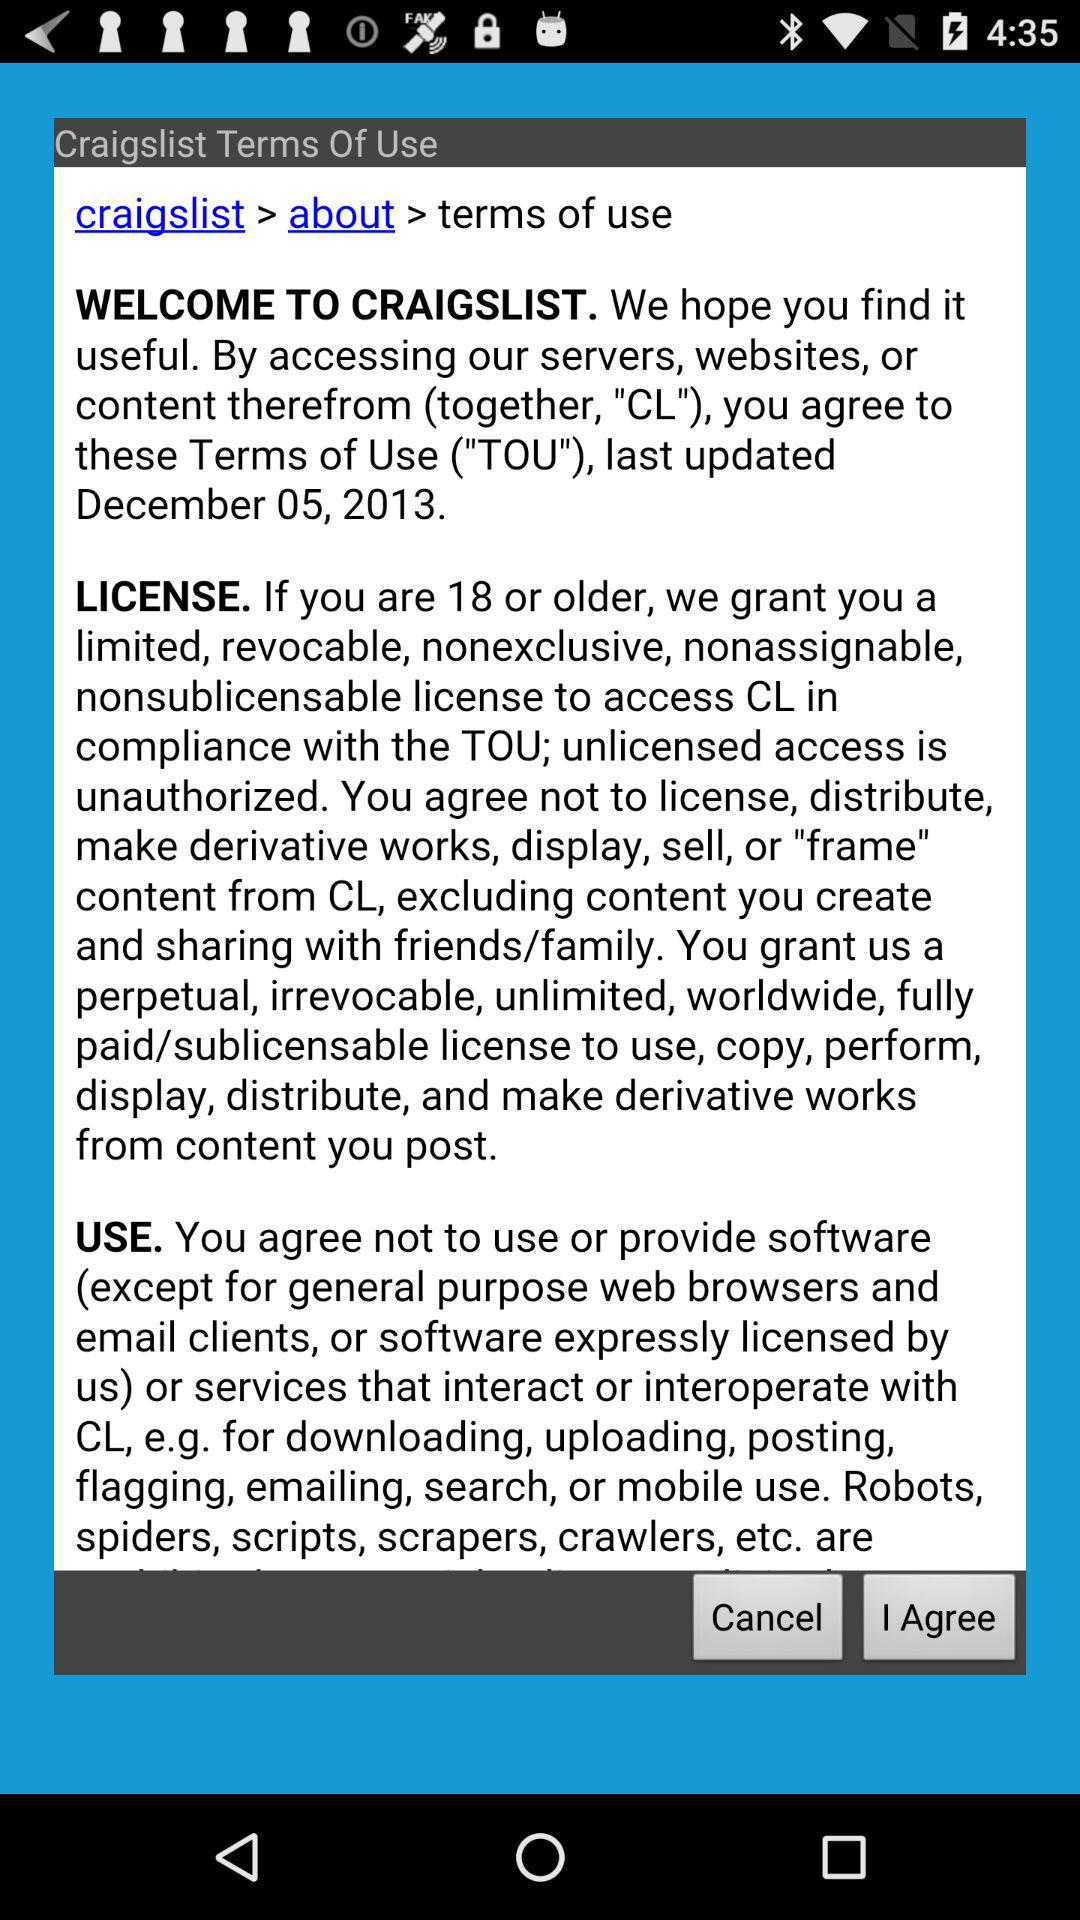What is the age limit for the license? The age limit for the license is 18 years or older. 